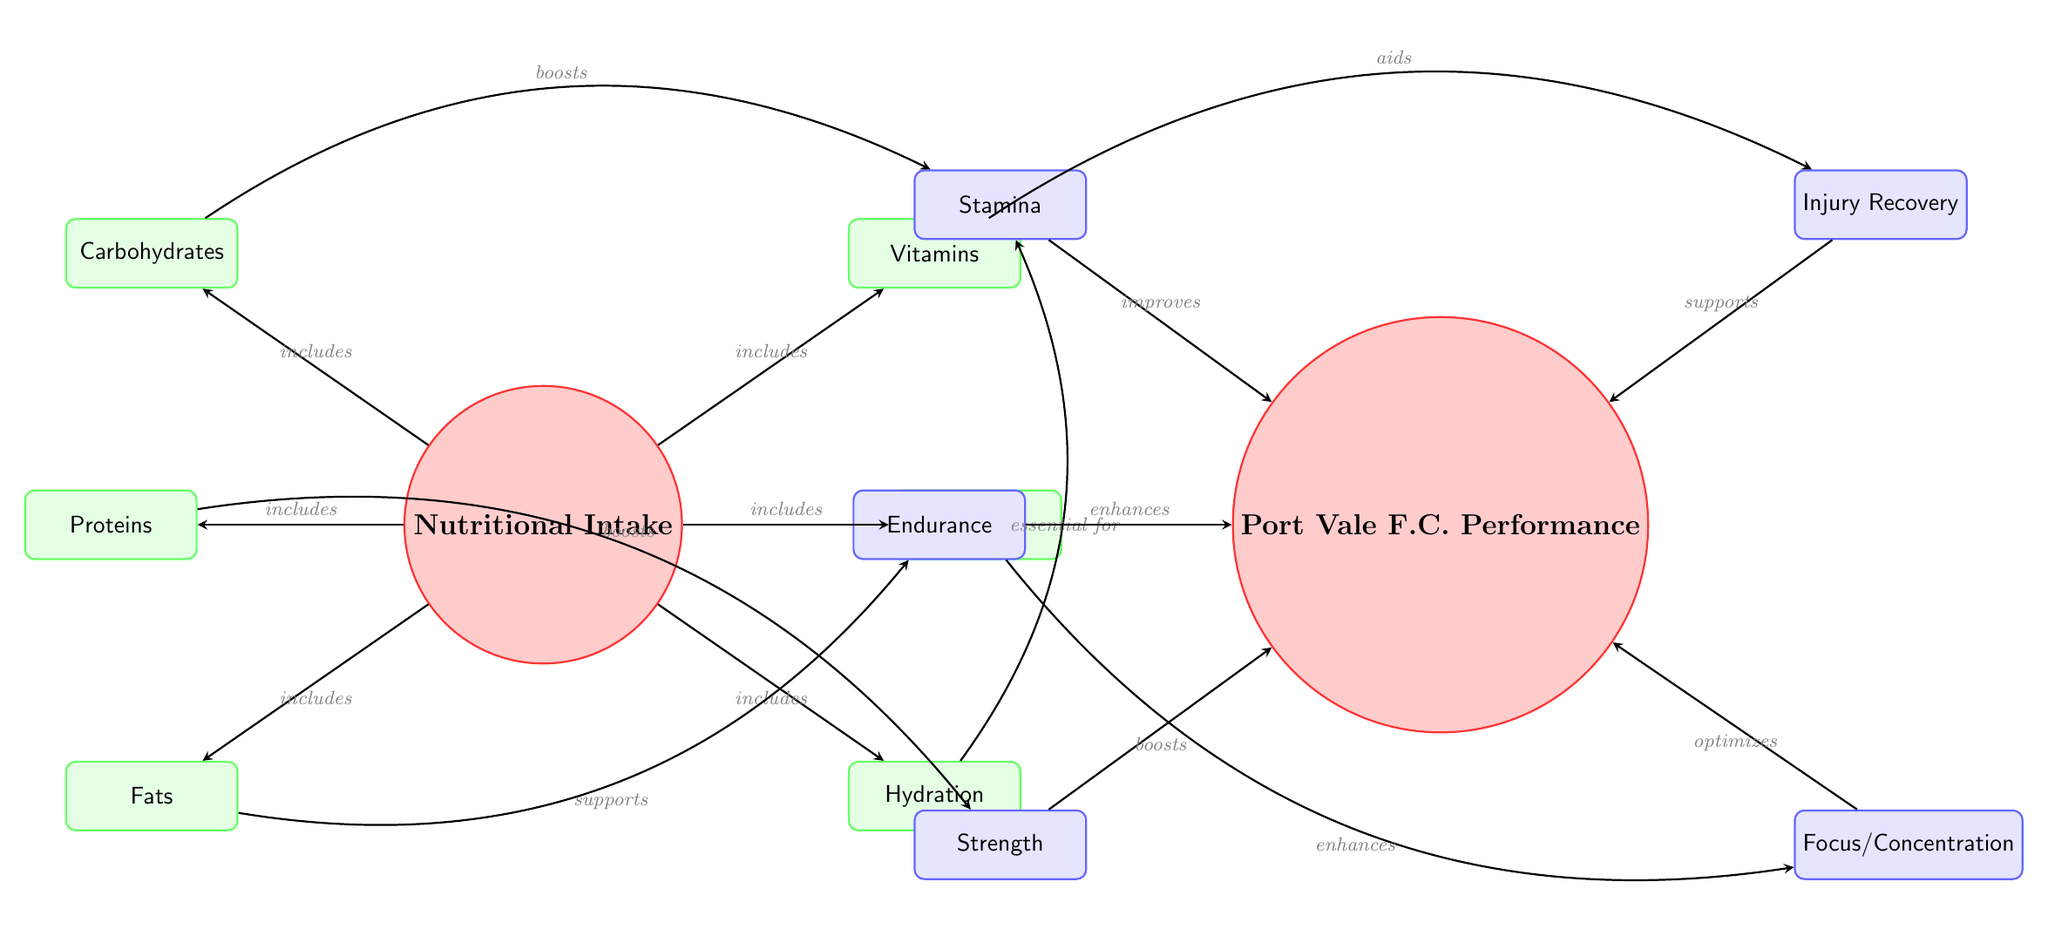What are the main categories of nutritional intake? The diagram reveals that there are six main categories under nutritional intake: Carbohydrates, Proteins, Fats, Vitamins, Minerals, and Hydration. They are represented as leaf nodes branching from the main node labeled "Nutritional Intake."
Answer: Carbohydrates, Proteins, Fats, Vitamins, Minerals, Hydration Which nutritional element is associated with stamina? The diagram illustrates an arrow between Carbohydrates and Stamina, signifying that carbohydrates boost stamina. This direct relationship indicates that carbohydrates play a vital role in enhancing this performance metric.
Answer: Carbohydrates How many performance aspects are connected to nutritional intake? There are five distinct performance aspects linked to nutritional intake in the diagram: Stamina, Endurance, Strength, Injury Recovery, and Focus/Concentration. These are all located in the performance section of the diagram, showing how nutritional intake affects performance overall.
Answer: Five What is the role of fats according to the diagram? The diagram highlights that fats support endurance, indicated by the arrow between the fats node and the endurance node. This clearly defines the relationship that fats have in enhancing a specific aspect of performance.
Answer: Supports Which nutritional component enhances focus? The connection in the diagram shows that Minerals enhance focus, as depicted by the directed arrow indicating enhancement. This demonstrates the cognitive impact of proper mineral intake on overall performance, particularly in maintaining focus.
Answer: Minerals What directly improves performance through stamina? The arrow leads from Stamina to the Performance node, indicating that improvements in stamina contribute to overall performance improvements. This illustrates the importance of stamina in achieving better performance outcomes for the players.
Answer: Improves How does hydration affect stamina according to the diagram? The diagram explicitly shows that Hydration is essential for stamina, as indicated by the directed arrow labeled "essential for." This means that adequate hydration must be maintained to support stamina levels effectively.
Answer: Essential for Which nutritional intake component is linked to injury recovery? According to the diagram, Vitamins are the component that aids in injury recovery as denoted by the arrow pointing from Vitamins to the Injury Recovery node. This signifies the importance of vitamins in the recuperation process for athletes.
Answer: Vitamins What boosts strength in footballers as per the diagram? The diagram indicates that Proteins boost strength, shown by the arrow linking the proteins node to the strength node. This relationship highlights the essential role proteins play in enhancing muscular capacity and overall physical performance.
Answer: Boosts 